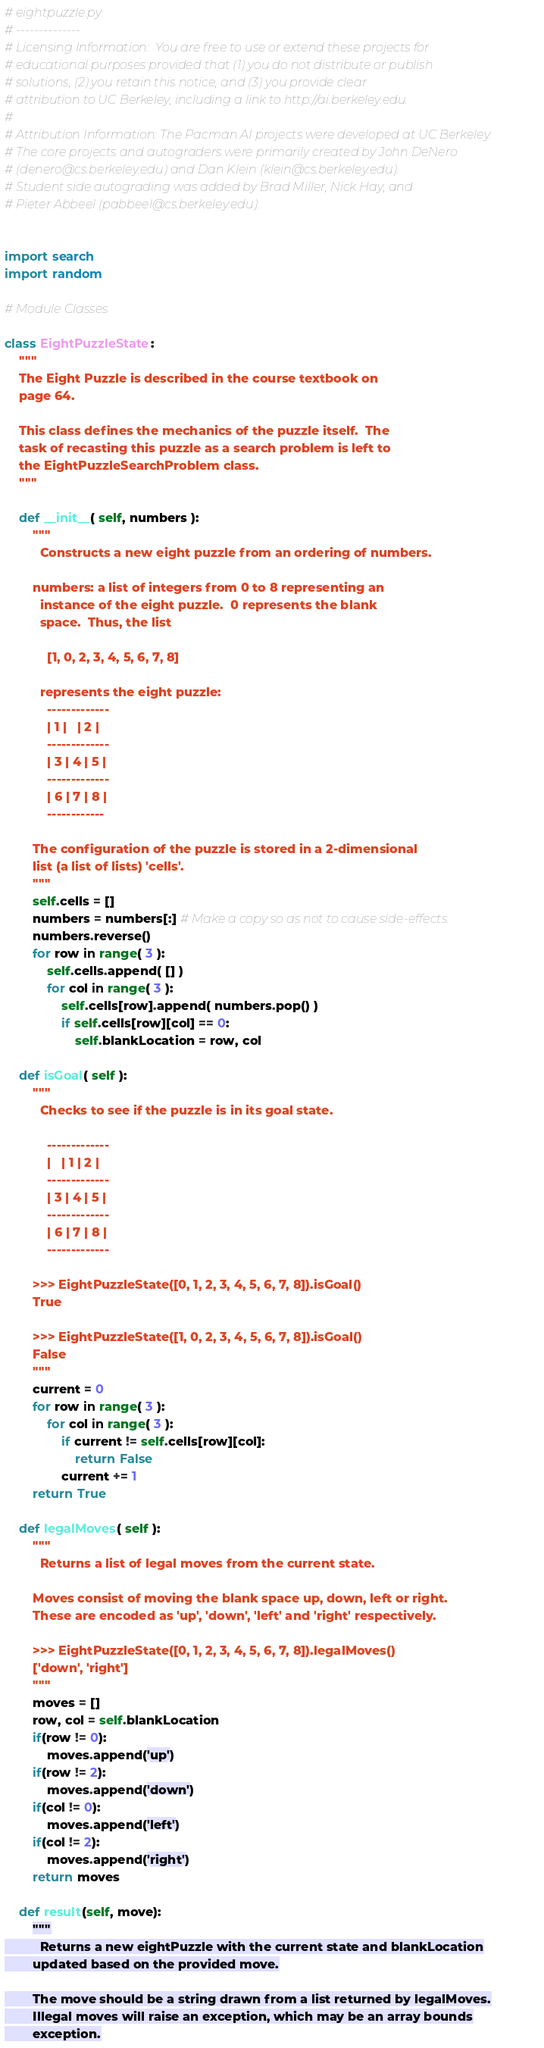Convert code to text. <code><loc_0><loc_0><loc_500><loc_500><_Python_># eightpuzzle.py
# --------------
# Licensing Information:  You are free to use or extend these projects for
# educational purposes provided that (1) you do not distribute or publish
# solutions, (2) you retain this notice, and (3) you provide clear
# attribution to UC Berkeley, including a link to http://ai.berkeley.edu.
# 
# Attribution Information: The Pacman AI projects were developed at UC Berkeley.
# The core projects and autograders were primarily created by John DeNero
# (denero@cs.berkeley.edu) and Dan Klein (klein@cs.berkeley.edu).
# Student side autograding was added by Brad Miller, Nick Hay, and
# Pieter Abbeel (pabbeel@cs.berkeley.edu).


import search
import random

# Module Classes

class EightPuzzleState:
    """
    The Eight Puzzle is described in the course textbook on
    page 64.

    This class defines the mechanics of the puzzle itself.  The
    task of recasting this puzzle as a search problem is left to
    the EightPuzzleSearchProblem class.
    """

    def __init__( self, numbers ):
        """
          Constructs a new eight puzzle from an ordering of numbers.

        numbers: a list of integers from 0 to 8 representing an
          instance of the eight puzzle.  0 represents the blank
          space.  Thus, the list

            [1, 0, 2, 3, 4, 5, 6, 7, 8]

          represents the eight puzzle:
            -------------
            | 1 |   | 2 |
            -------------
            | 3 | 4 | 5 |
            -------------
            | 6 | 7 | 8 |
            ------------

        The configuration of the puzzle is stored in a 2-dimensional
        list (a list of lists) 'cells'.
        """
        self.cells = []
        numbers = numbers[:] # Make a copy so as not to cause side-effects.
        numbers.reverse()
        for row in range( 3 ):
            self.cells.append( [] )
            for col in range( 3 ):
                self.cells[row].append( numbers.pop() )
                if self.cells[row][col] == 0:
                    self.blankLocation = row, col

    def isGoal( self ):
        """
          Checks to see if the puzzle is in its goal state.

            -------------
            |   | 1 | 2 |
            -------------
            | 3 | 4 | 5 |
            -------------
            | 6 | 7 | 8 |
            -------------

        >>> EightPuzzleState([0, 1, 2, 3, 4, 5, 6, 7, 8]).isGoal()
        True

        >>> EightPuzzleState([1, 0, 2, 3, 4, 5, 6, 7, 8]).isGoal()
        False
        """
        current = 0
        for row in range( 3 ):
            for col in range( 3 ):
                if current != self.cells[row][col]:
                    return False
                current += 1
        return True

    def legalMoves( self ):
        """
          Returns a list of legal moves from the current state.

        Moves consist of moving the blank space up, down, left or right.
        These are encoded as 'up', 'down', 'left' and 'right' respectively.

        >>> EightPuzzleState([0, 1, 2, 3, 4, 5, 6, 7, 8]).legalMoves()
        ['down', 'right']
        """
        moves = []
        row, col = self.blankLocation
        if(row != 0):
            moves.append('up')
        if(row != 2):
            moves.append('down')
        if(col != 0):
            moves.append('left')
        if(col != 2):
            moves.append('right')
        return moves

    def result(self, move):
        """
          Returns a new eightPuzzle with the current state and blankLocation
        updated based on the provided move.

        The move should be a string drawn from a list returned by legalMoves.
        Illegal moves will raise an exception, which may be an array bounds
        exception.
</code> 